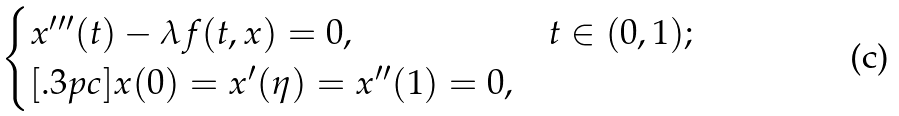Convert formula to latex. <formula><loc_0><loc_0><loc_500><loc_500>\begin{cases} x ^ { \prime \prime \prime } ( t ) - \lambda f ( t , x ) = 0 , & t \in ( 0 , 1 ) ; \\ [ . 3 p c ] x ( 0 ) = x ^ { \prime } ( \eta ) = x ^ { \prime \prime } ( 1 ) = 0 , & \end{cases}</formula> 